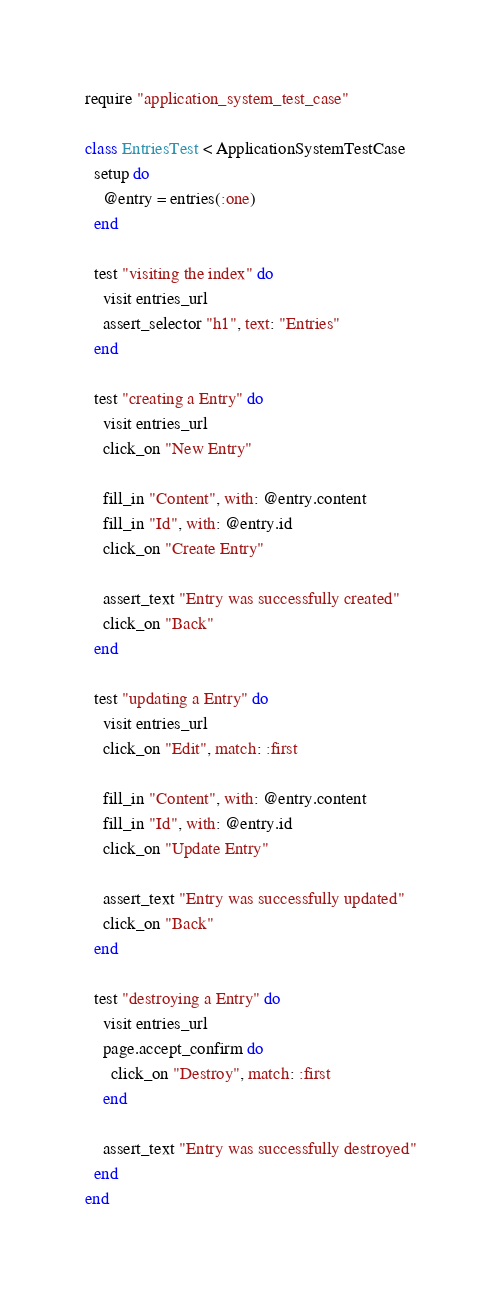Convert code to text. <code><loc_0><loc_0><loc_500><loc_500><_Ruby_>require "application_system_test_case"

class EntriesTest < ApplicationSystemTestCase
  setup do
    @entry = entries(:one)
  end

  test "visiting the index" do
    visit entries_url
    assert_selector "h1", text: "Entries"
  end

  test "creating a Entry" do
    visit entries_url
    click_on "New Entry"

    fill_in "Content", with: @entry.content
    fill_in "Id", with: @entry.id
    click_on "Create Entry"

    assert_text "Entry was successfully created"
    click_on "Back"
  end

  test "updating a Entry" do
    visit entries_url
    click_on "Edit", match: :first

    fill_in "Content", with: @entry.content
    fill_in "Id", with: @entry.id
    click_on "Update Entry"

    assert_text "Entry was successfully updated"
    click_on "Back"
  end

  test "destroying a Entry" do
    visit entries_url
    page.accept_confirm do
      click_on "Destroy", match: :first
    end

    assert_text "Entry was successfully destroyed"
  end
end
</code> 